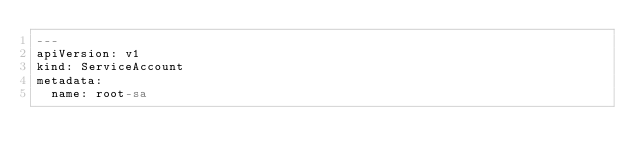Convert code to text. <code><loc_0><loc_0><loc_500><loc_500><_YAML_>---
apiVersion: v1
kind: ServiceAccount
metadata:
  name: root-sa
</code> 